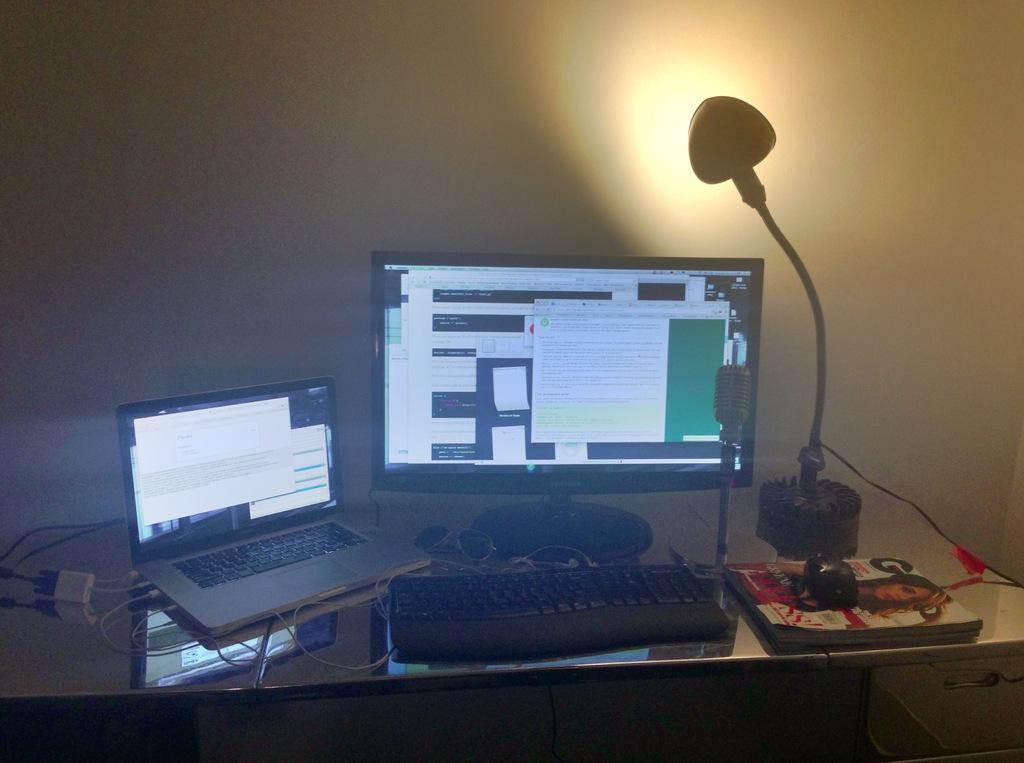<image>
Give a short and clear explanation of the subsequent image. Two laptops next to a magazine cover that has the letter "G" on it. 